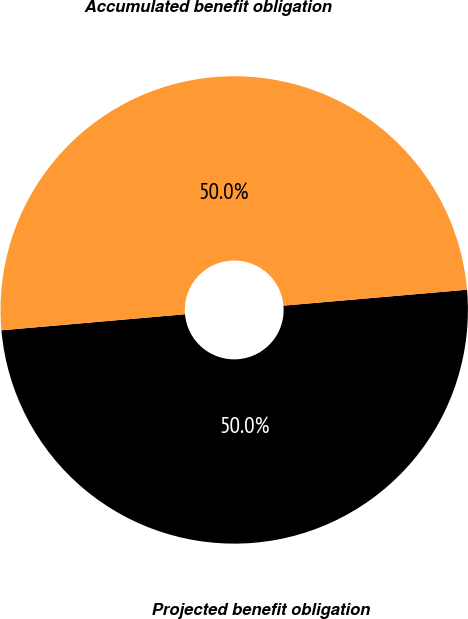<chart> <loc_0><loc_0><loc_500><loc_500><pie_chart><fcel>Projected benefit obligation<fcel>Accumulated benefit obligation<nl><fcel>49.99%<fcel>50.01%<nl></chart> 